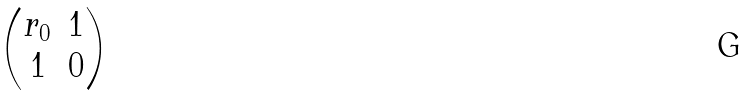<formula> <loc_0><loc_0><loc_500><loc_500>\begin{pmatrix} r _ { 0 } & 1 \\ 1 & 0 \end{pmatrix}</formula> 